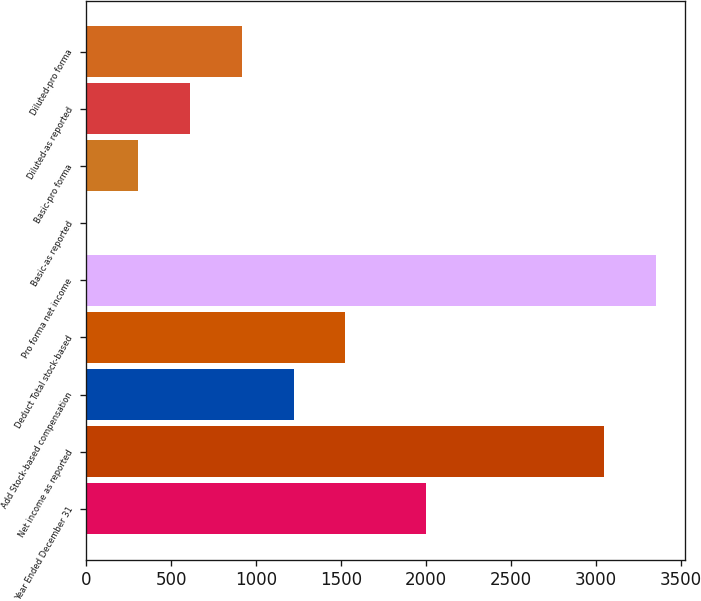Convert chart. <chart><loc_0><loc_0><loc_500><loc_500><bar_chart><fcel>Year Ended December 31<fcel>Net income as reported<fcel>Add Stock-based compensation<fcel>Deduct Total stock-based<fcel>Pro forma net income<fcel>Basic-as reported<fcel>Basic-pro forma<fcel>Diluted-as reported<fcel>Diluted-pro forma<nl><fcel>2002<fcel>3050<fcel>1220.75<fcel>1525.63<fcel>3354.88<fcel>1.23<fcel>306.11<fcel>610.99<fcel>915.87<nl></chart> 